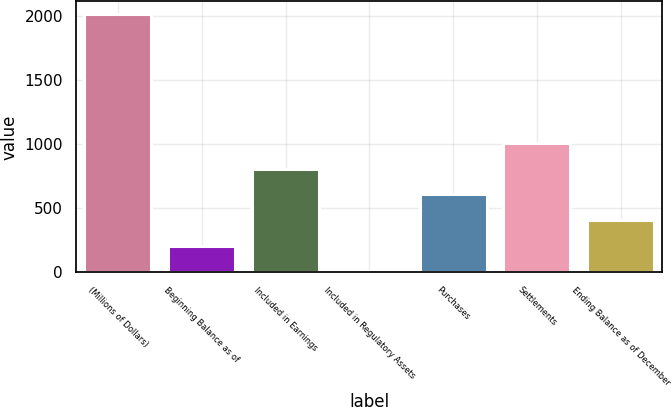Convert chart. <chart><loc_0><loc_0><loc_500><loc_500><bar_chart><fcel>(Millions of Dollars)<fcel>Beginning Balance as of<fcel>Included in Earnings<fcel>Included in Regulatory Assets<fcel>Purchases<fcel>Settlements<fcel>Ending Balance as of December<nl><fcel>2014<fcel>207.7<fcel>809.8<fcel>7<fcel>609.1<fcel>1010.5<fcel>408.4<nl></chart> 